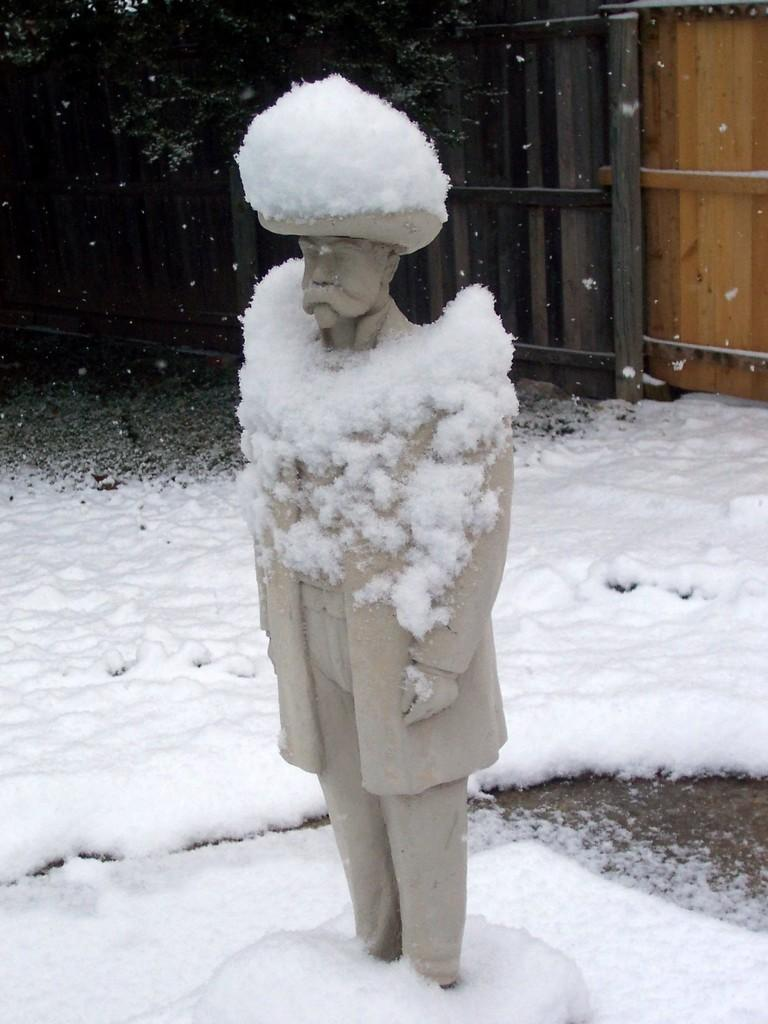What is the main subject of the picture? There is a sculpture in the picture. What is the condition of the ground in the image? There is snow on the ground. Is the sculpture also affected by the snow? Yes, there is snow on the sculpture. What can be seen in the background of the picture? There is fencing in the background of the picture. What type of rake is being used to create the sculpture in the image? There is no rake present in the image, and the sculpture is already created. What metal is used to construct the fencing in the background? The type of metal used for the fencing is not mentioned in the image, so it cannot be determined. 